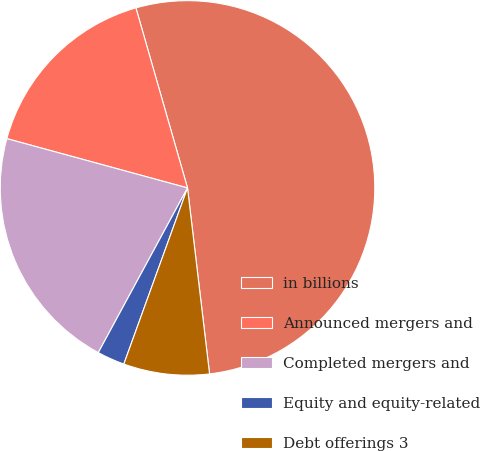Convert chart to OTSL. <chart><loc_0><loc_0><loc_500><loc_500><pie_chart><fcel>in billions<fcel>Announced mergers and<fcel>Completed mergers and<fcel>Equity and equity-related<fcel>Debt offerings 3<nl><fcel>52.57%<fcel>16.32%<fcel>21.34%<fcel>2.38%<fcel>7.4%<nl></chart> 